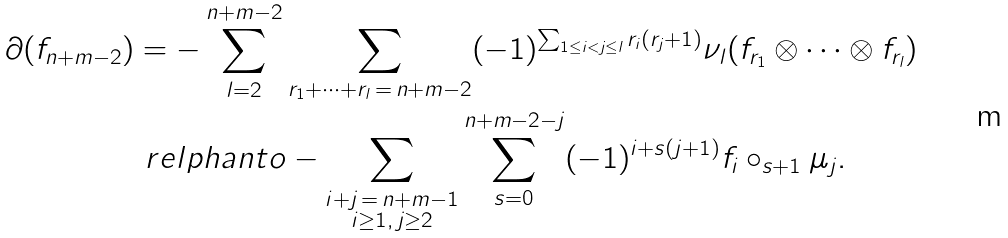Convert formula to latex. <formula><loc_0><loc_0><loc_500><loc_500>\partial ( f _ { n + m - 2 } ) & = - \sum _ { l = 2 } ^ { n + m - 2 } \sum _ { r _ { 1 } + \cdots + r _ { l } \, = \, n + m - 2 } ( - 1 ) ^ { \sum _ { 1 \leq i < j \leq l } r _ { i } ( r _ { j } + 1 ) } \nu _ { l } ( f _ { r _ { 1 } } \otimes \cdots \otimes f _ { r _ { l } } ) \\ & \ r e l p h a n t o - \sum _ { \substack { i + j \, = \, n + m - 1 \\ i \geq 1 , \, j \geq 2 } } \sum _ { s = 0 } ^ { n + m - 2 - j } ( - 1 ) ^ { i + s ( j + 1 ) } f _ { i } \circ _ { s + 1 } \mu _ { j } .</formula> 